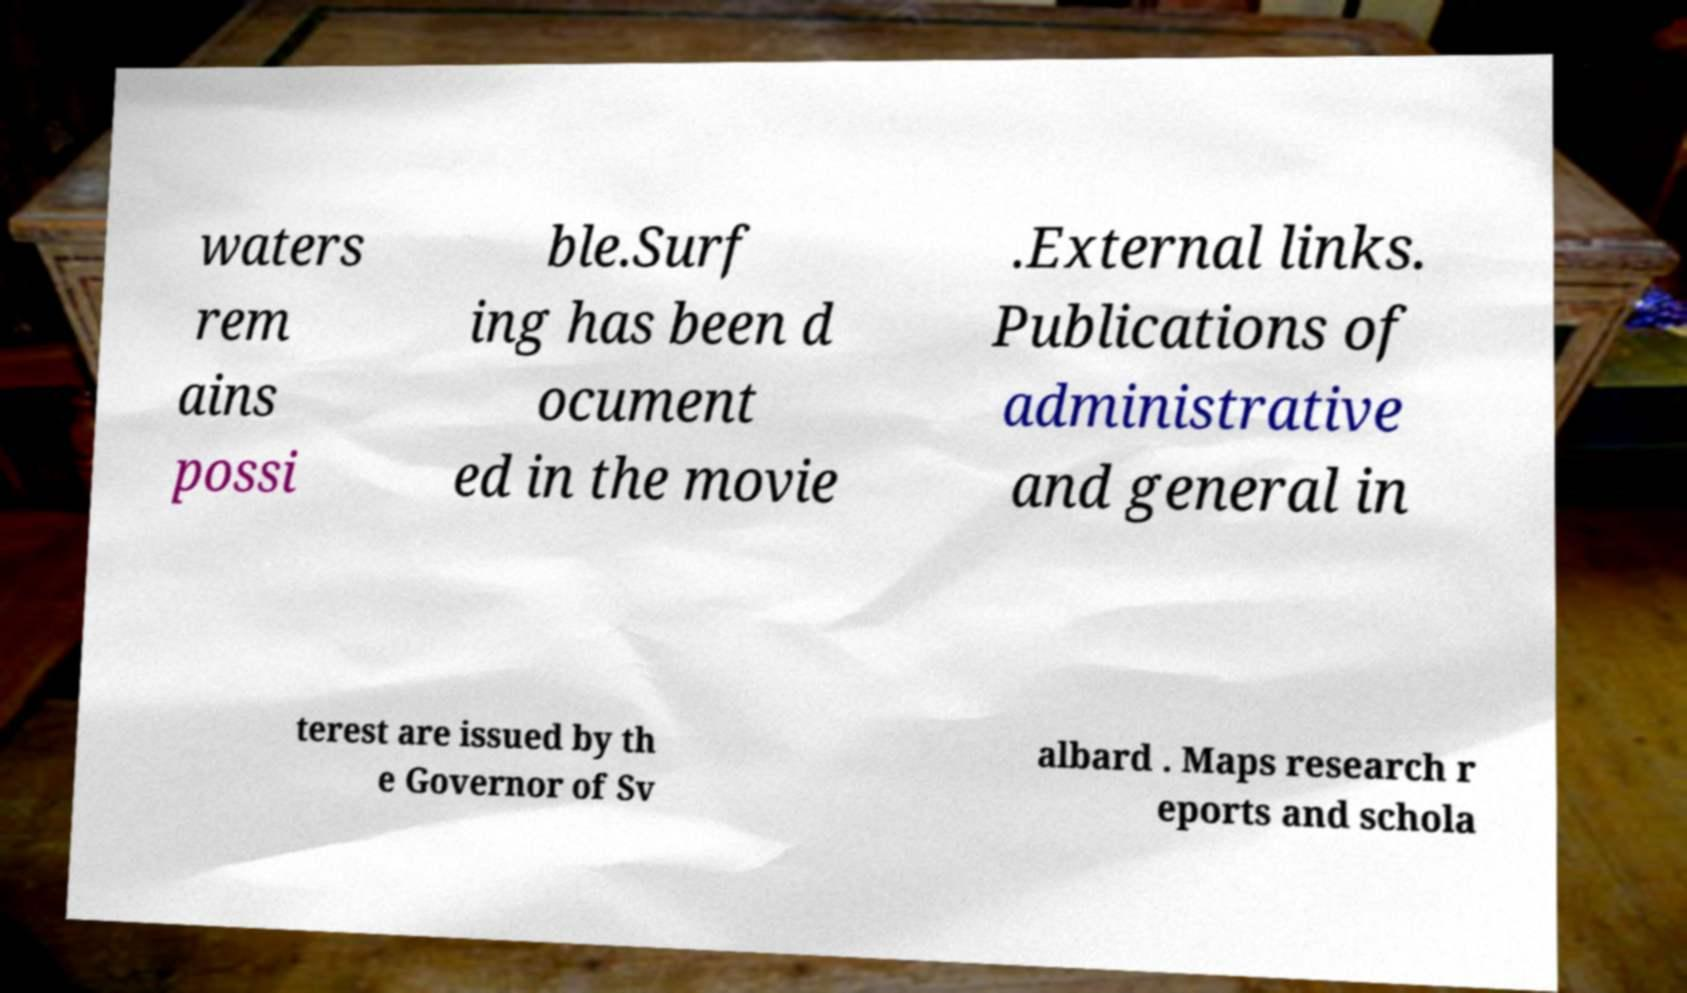Could you assist in decoding the text presented in this image and type it out clearly? waters rem ains possi ble.Surf ing has been d ocument ed in the movie .External links. Publications of administrative and general in terest are issued by th e Governor of Sv albard . Maps research r eports and schola 